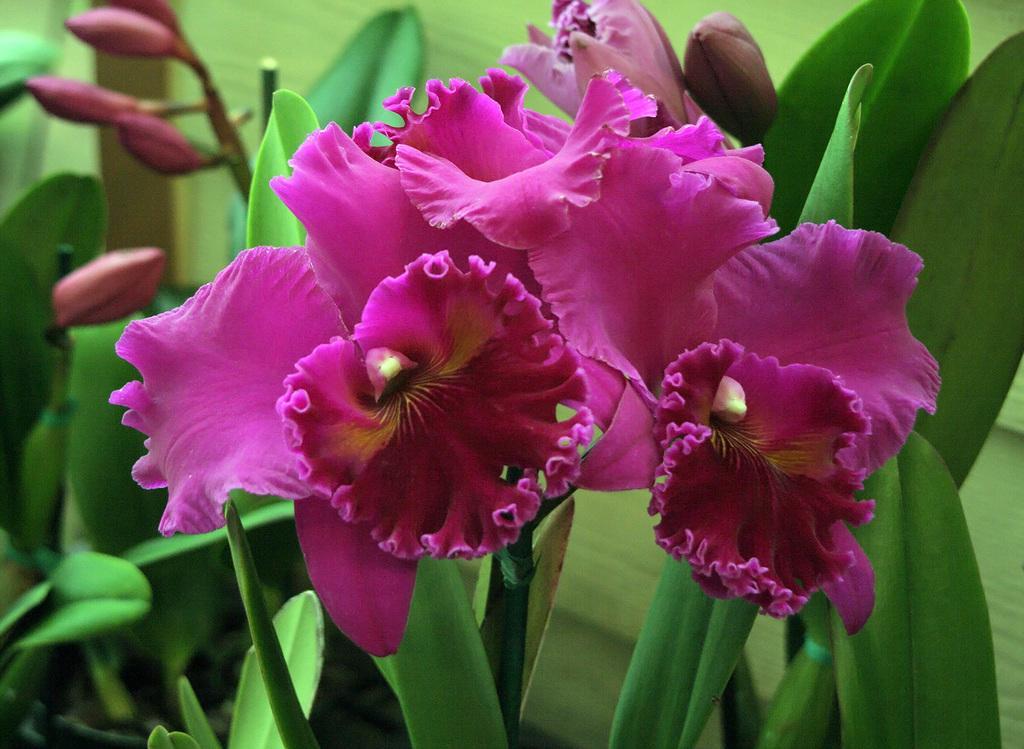Can you describe this image briefly? In this image I can see the pink color flowers and the buds to the plants. I can see the plants are in green color. 